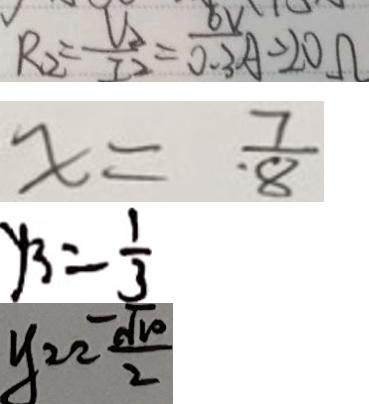Convert formula to latex. <formula><loc_0><loc_0><loc_500><loc_500>R _ { 2 } = \frac { V _ { 2 } } { I _ { 2 } } = \frac { 6 V } { 0 . 3 } A = 2 0 \Omega 
 x = \frac { 7 } { 8 } 
 y _ { 3 } = \frac { 1 } { 3 } 
 y = 2 \frac { \sqrt { 1 0 } } { 2 }</formula> 